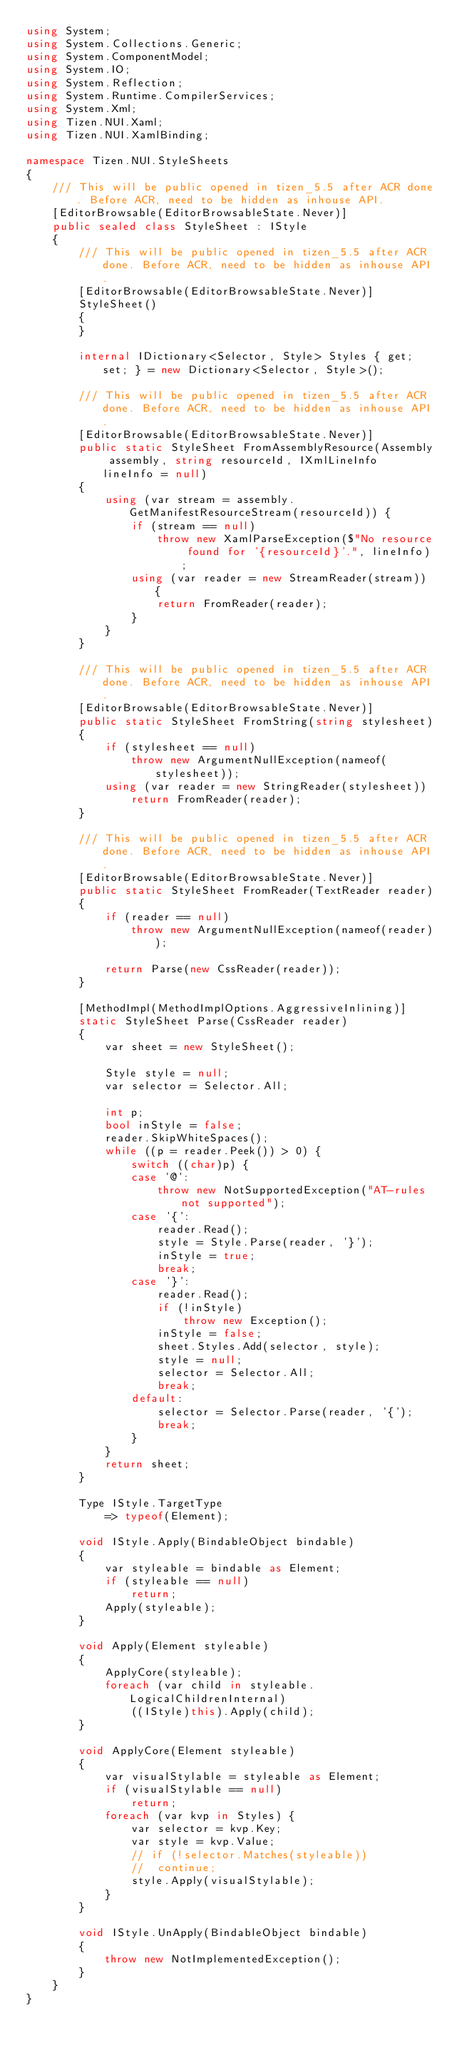Convert code to text. <code><loc_0><loc_0><loc_500><loc_500><_C#_>using System;
using System.Collections.Generic;
using System.ComponentModel;
using System.IO;
using System.Reflection;
using System.Runtime.CompilerServices;
using System.Xml;
using Tizen.NUI.Xaml;
using Tizen.NUI.XamlBinding;

namespace Tizen.NUI.StyleSheets
{
    /// This will be public opened in tizen_5.5 after ACR done. Before ACR, need to be hidden as inhouse API.
    [EditorBrowsable(EditorBrowsableState.Never)]
    public sealed class StyleSheet : IStyle
    {
        /// This will be public opened in tizen_5.5 after ACR done. Before ACR, need to be hidden as inhouse API.
        [EditorBrowsable(EditorBrowsableState.Never)]
        StyleSheet()
        {
        }

        internal IDictionary<Selector, Style> Styles { get; set; } = new Dictionary<Selector, Style>();

        /// This will be public opened in tizen_5.5 after ACR done. Before ACR, need to be hidden as inhouse API.
        [EditorBrowsable(EditorBrowsableState.Never)]
        public static StyleSheet FromAssemblyResource(Assembly assembly, string resourceId, IXmlLineInfo lineInfo = null)
        {
            using (var stream = assembly.GetManifestResourceStream(resourceId)) {
                if (stream == null)
                    throw new XamlParseException($"No resource found for '{resourceId}'.", lineInfo);
                using (var reader = new StreamReader(stream)) {
                    return FromReader(reader);
                }
            }
        }

        /// This will be public opened in tizen_5.5 after ACR done. Before ACR, need to be hidden as inhouse API.
        [EditorBrowsable(EditorBrowsableState.Never)]
        public static StyleSheet FromString(string stylesheet)
        {
            if (stylesheet == null)
                throw new ArgumentNullException(nameof(stylesheet));
            using (var reader = new StringReader(stylesheet))
                return FromReader(reader);
        }

        /// This will be public opened in tizen_5.5 after ACR done. Before ACR, need to be hidden as inhouse API.
        [EditorBrowsable(EditorBrowsableState.Never)]
        public static StyleSheet FromReader(TextReader reader)
        {
            if (reader == null)
                throw new ArgumentNullException(nameof(reader));

            return Parse(new CssReader(reader));
        }

        [MethodImpl(MethodImplOptions.AggressiveInlining)]
        static StyleSheet Parse(CssReader reader)
        {
            var sheet = new StyleSheet();

            Style style = null;
            var selector = Selector.All;

            int p;
            bool inStyle = false;
            reader.SkipWhiteSpaces();
            while ((p = reader.Peek()) > 0) {
                switch ((char)p) {
                case '@':
                    throw new NotSupportedException("AT-rules not supported");
                case '{':
                    reader.Read();
                    style = Style.Parse(reader, '}');
                    inStyle = true;
                    break;
                case '}':
                    reader.Read();
                    if (!inStyle)
                        throw new Exception();
                    inStyle = false;
                    sheet.Styles.Add(selector, style);
                    style = null;
                    selector = Selector.All;
                    break;
                default:
                    selector = Selector.Parse(reader, '{');
                    break;
                }
            }
            return sheet;
        }

        Type IStyle.TargetType
            => typeof(Element);

        void IStyle.Apply(BindableObject bindable)
        {
            var styleable = bindable as Element;
            if (styleable == null)
                return;
            Apply(styleable);
        }

        void Apply(Element styleable)
        {
            ApplyCore(styleable);
            foreach (var child in styleable.LogicalChildrenInternal)
                ((IStyle)this).Apply(child);
        }

        void ApplyCore(Element styleable)
        {
            var visualStylable = styleable as Element;
            if (visualStylable == null)
                return;
            foreach (var kvp in Styles) {
                var selector = kvp.Key;
                var style = kvp.Value;
                // if (!selector.Matches(styleable))
                // 	continue;
                style.Apply(visualStylable);
            }
        }

        void IStyle.UnApply(BindableObject bindable)
        {
            throw new NotImplementedException();
        }
    }
}</code> 